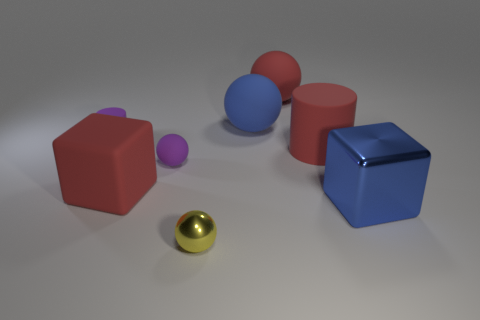What number of red blocks are on the left side of the red rubber sphere?
Your response must be concise. 1. Are there more big blue balls than big red things?
Your response must be concise. No. The ball that is the same color as the shiny cube is what size?
Provide a short and direct response. Large. How big is the ball that is in front of the tiny purple cylinder and behind the blue cube?
Your response must be concise. Small. There is a ball that is in front of the big blue object that is in front of the small purple object that is left of the big rubber block; what is it made of?
Provide a short and direct response. Metal. What is the material of the big cube that is the same color as the big rubber cylinder?
Your response must be concise. Rubber. Is the color of the big block on the right side of the big blue sphere the same as the big sphere to the left of the red rubber sphere?
Offer a very short reply. Yes. The tiny rubber thing that is behind the cylinder that is to the right of the big red object in front of the large rubber cylinder is what shape?
Provide a short and direct response. Cylinder. There is a object that is both in front of the red block and behind the yellow thing; what shape is it?
Make the answer very short. Cube. There is a large red rubber object that is on the left side of the small purple rubber thing that is in front of the purple cylinder; how many blue spheres are right of it?
Your response must be concise. 1. 